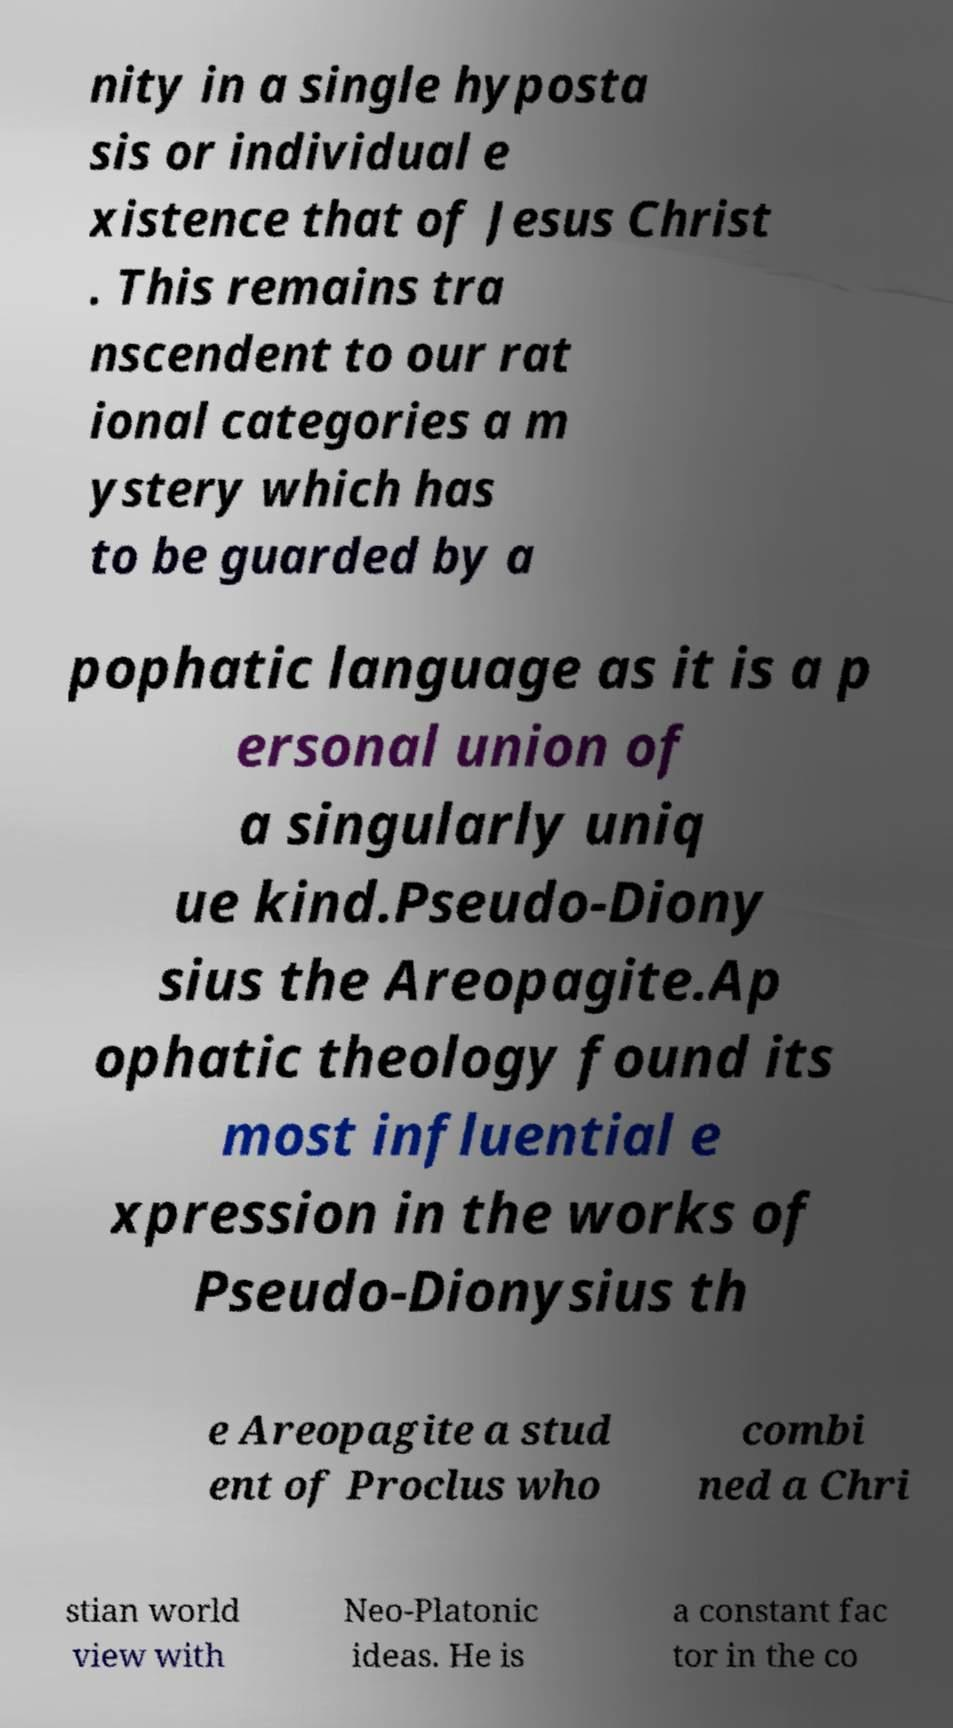Please read and relay the text visible in this image. What does it say? nity in a single hyposta sis or individual e xistence that of Jesus Christ . This remains tra nscendent to our rat ional categories a m ystery which has to be guarded by a pophatic language as it is a p ersonal union of a singularly uniq ue kind.Pseudo-Diony sius the Areopagite.Ap ophatic theology found its most influential e xpression in the works of Pseudo-Dionysius th e Areopagite a stud ent of Proclus who combi ned a Chri stian world view with Neo-Platonic ideas. He is a constant fac tor in the co 